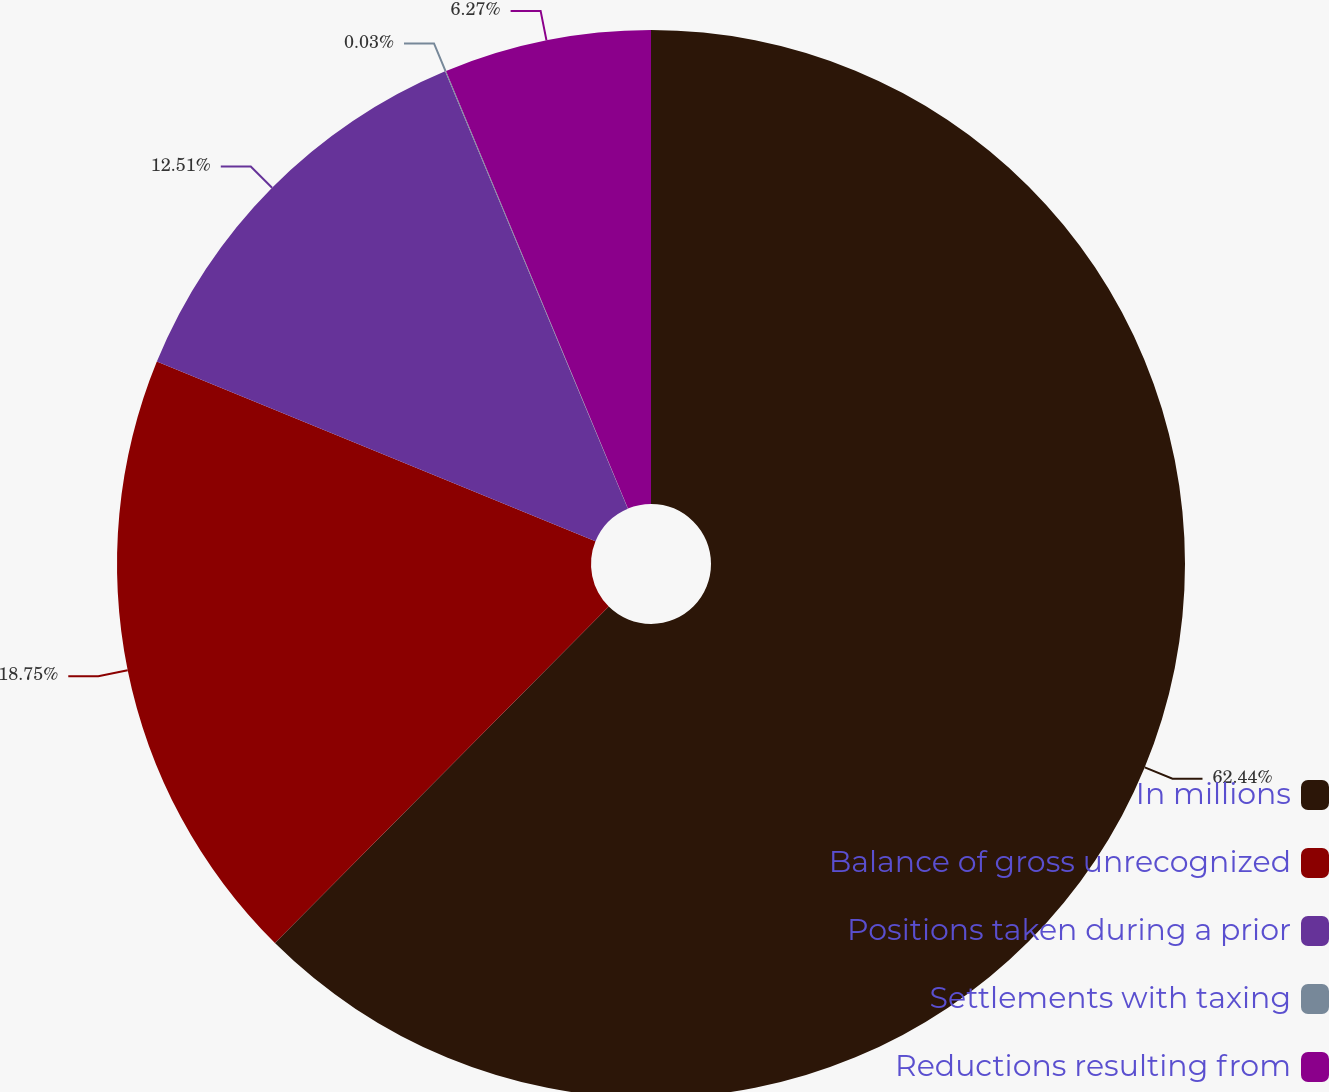Convert chart. <chart><loc_0><loc_0><loc_500><loc_500><pie_chart><fcel>In millions<fcel>Balance of gross unrecognized<fcel>Positions taken during a prior<fcel>Settlements with taxing<fcel>Reductions resulting from<nl><fcel>62.43%<fcel>18.75%<fcel>12.51%<fcel>0.03%<fcel>6.27%<nl></chart> 